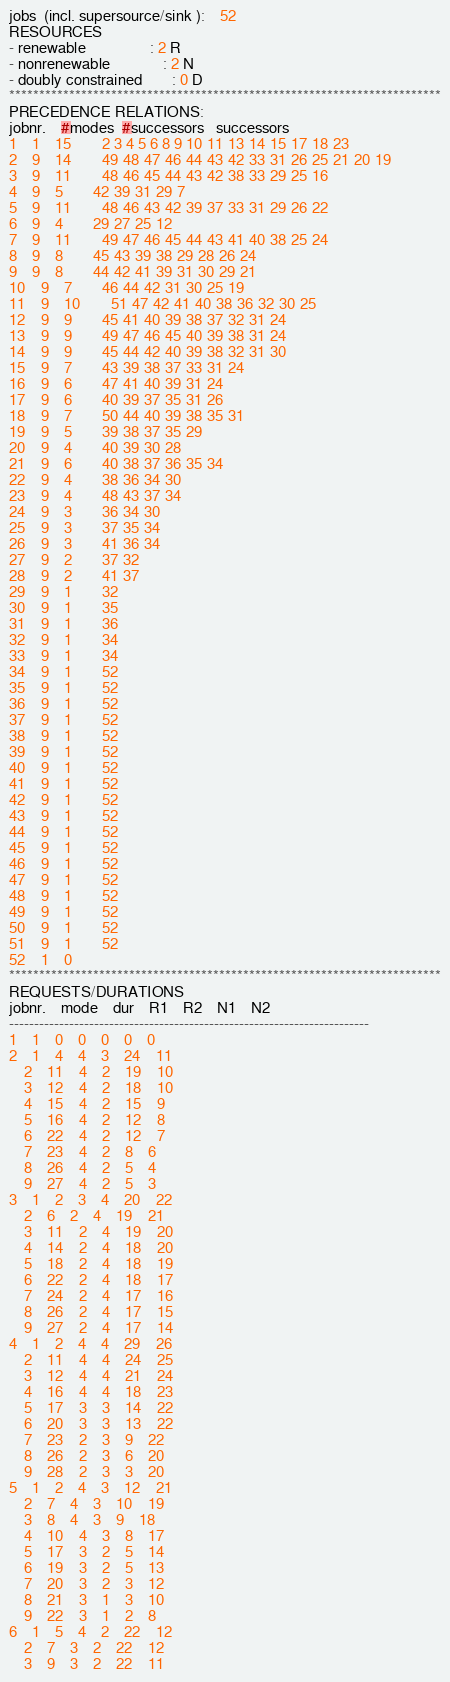<code> <loc_0><loc_0><loc_500><loc_500><_ObjectiveC_>jobs  (incl. supersource/sink ):	52
RESOURCES
- renewable                 : 2 R
- nonrenewable              : 2 N
- doubly constrained        : 0 D
************************************************************************
PRECEDENCE RELATIONS:
jobnr.    #modes  #successors   successors
1	1	15		2 3 4 5 6 8 9 10 11 13 14 15 17 18 23 
2	9	14		49 48 47 46 44 43 42 33 31 26 25 21 20 19 
3	9	11		48 46 45 44 43 42 38 33 29 25 16 
4	9	5		42 39 31 29 7 
5	9	11		48 46 43 42 39 37 33 31 29 26 22 
6	9	4		29 27 25 12 
7	9	11		49 47 46 45 44 43 41 40 38 25 24 
8	9	8		45 43 39 38 29 28 26 24 
9	9	8		44 42 41 39 31 30 29 21 
10	9	7		46 44 42 31 30 25 19 
11	9	10		51 47 42 41 40 38 36 32 30 25 
12	9	9		45 41 40 39 38 37 32 31 24 
13	9	9		49 47 46 45 40 39 38 31 24 
14	9	9		45 44 42 40 39 38 32 31 30 
15	9	7		43 39 38 37 33 31 24 
16	9	6		47 41 40 39 31 24 
17	9	6		40 39 37 35 31 26 
18	9	7		50 44 40 39 38 35 31 
19	9	5		39 38 37 35 29 
20	9	4		40 39 30 28 
21	9	6		40 38 37 36 35 34 
22	9	4		38 36 34 30 
23	9	4		48 43 37 34 
24	9	3		36 34 30 
25	9	3		37 35 34 
26	9	3		41 36 34 
27	9	2		37 32 
28	9	2		41 37 
29	9	1		32 
30	9	1		35 
31	9	1		36 
32	9	1		34 
33	9	1		34 
34	9	1		52 
35	9	1		52 
36	9	1		52 
37	9	1		52 
38	9	1		52 
39	9	1		52 
40	9	1		52 
41	9	1		52 
42	9	1		52 
43	9	1		52 
44	9	1		52 
45	9	1		52 
46	9	1		52 
47	9	1		52 
48	9	1		52 
49	9	1		52 
50	9	1		52 
51	9	1		52 
52	1	0		
************************************************************************
REQUESTS/DURATIONS
jobnr.	mode	dur	R1	R2	N1	N2	
------------------------------------------------------------------------
1	1	0	0	0	0	0	
2	1	4	4	3	24	11	
	2	11	4	2	19	10	
	3	12	4	2	18	10	
	4	15	4	2	15	9	
	5	16	4	2	12	8	
	6	22	4	2	12	7	
	7	23	4	2	8	6	
	8	26	4	2	5	4	
	9	27	4	2	5	3	
3	1	2	3	4	20	22	
	2	6	2	4	19	21	
	3	11	2	4	19	20	
	4	14	2	4	18	20	
	5	18	2	4	18	19	
	6	22	2	4	18	17	
	7	24	2	4	17	16	
	8	26	2	4	17	15	
	9	27	2	4	17	14	
4	1	2	4	4	29	26	
	2	11	4	4	24	25	
	3	12	4	4	21	24	
	4	16	4	4	18	23	
	5	17	3	3	14	22	
	6	20	3	3	13	22	
	7	23	2	3	9	22	
	8	26	2	3	6	20	
	9	28	2	3	3	20	
5	1	2	4	3	12	21	
	2	7	4	3	10	19	
	3	8	4	3	9	18	
	4	10	4	3	8	17	
	5	17	3	2	5	14	
	6	19	3	2	5	13	
	7	20	3	2	3	12	
	8	21	3	1	3	10	
	9	22	3	1	2	8	
6	1	5	4	2	22	12	
	2	7	3	2	22	12	
	3	9	3	2	22	11	</code> 